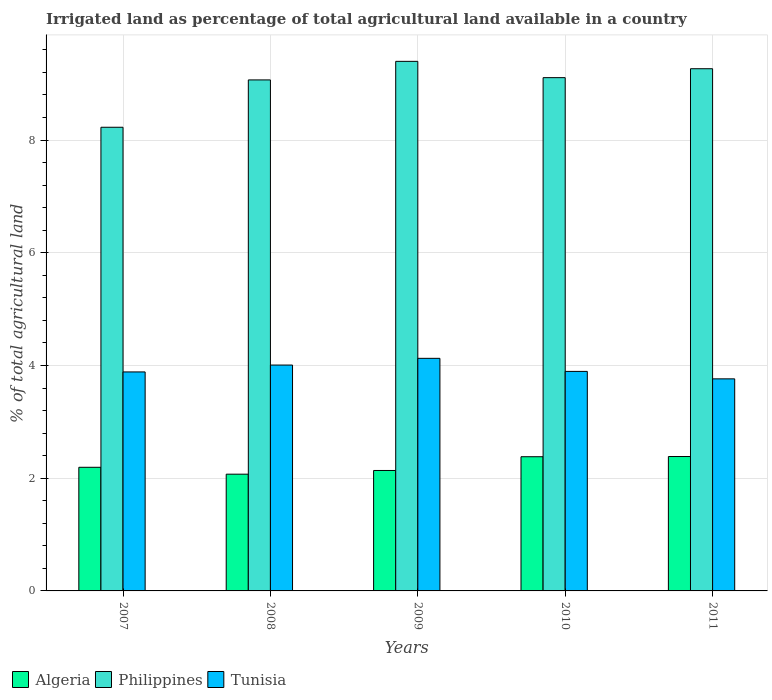How many different coloured bars are there?
Provide a short and direct response. 3. How many groups of bars are there?
Your answer should be compact. 5. Are the number of bars per tick equal to the number of legend labels?
Keep it short and to the point. Yes. Are the number of bars on each tick of the X-axis equal?
Make the answer very short. Yes. How many bars are there on the 4th tick from the left?
Your answer should be compact. 3. What is the percentage of irrigated land in Tunisia in 2009?
Offer a terse response. 4.13. Across all years, what is the maximum percentage of irrigated land in Algeria?
Ensure brevity in your answer.  2.38. Across all years, what is the minimum percentage of irrigated land in Philippines?
Your answer should be compact. 8.23. In which year was the percentage of irrigated land in Philippines minimum?
Provide a succinct answer. 2007. What is the total percentage of irrigated land in Tunisia in the graph?
Your answer should be compact. 19.68. What is the difference between the percentage of irrigated land in Tunisia in 2007 and that in 2009?
Provide a succinct answer. -0.24. What is the difference between the percentage of irrigated land in Algeria in 2011 and the percentage of irrigated land in Tunisia in 2009?
Give a very brief answer. -1.74. What is the average percentage of irrigated land in Algeria per year?
Your answer should be very brief. 2.23. In the year 2007, what is the difference between the percentage of irrigated land in Philippines and percentage of irrigated land in Tunisia?
Offer a terse response. 4.34. What is the ratio of the percentage of irrigated land in Algeria in 2008 to that in 2011?
Make the answer very short. 0.87. Is the percentage of irrigated land in Tunisia in 2010 less than that in 2011?
Your answer should be very brief. No. What is the difference between the highest and the second highest percentage of irrigated land in Algeria?
Provide a succinct answer. 0. What is the difference between the highest and the lowest percentage of irrigated land in Tunisia?
Offer a terse response. 0.36. In how many years, is the percentage of irrigated land in Algeria greater than the average percentage of irrigated land in Algeria taken over all years?
Provide a short and direct response. 2. Is the sum of the percentage of irrigated land in Algeria in 2007 and 2010 greater than the maximum percentage of irrigated land in Tunisia across all years?
Your answer should be very brief. Yes. What does the 2nd bar from the left in 2007 represents?
Offer a terse response. Philippines. What does the 2nd bar from the right in 2008 represents?
Keep it short and to the point. Philippines. How many years are there in the graph?
Ensure brevity in your answer.  5. Are the values on the major ticks of Y-axis written in scientific E-notation?
Your answer should be compact. No. How many legend labels are there?
Keep it short and to the point. 3. How are the legend labels stacked?
Keep it short and to the point. Horizontal. What is the title of the graph?
Make the answer very short. Irrigated land as percentage of total agricultural land available in a country. Does "Palau" appear as one of the legend labels in the graph?
Offer a very short reply. No. What is the label or title of the X-axis?
Your answer should be compact. Years. What is the label or title of the Y-axis?
Your answer should be compact. % of total agricultural land. What is the % of total agricultural land of Algeria in 2007?
Offer a terse response. 2.19. What is the % of total agricultural land of Philippines in 2007?
Keep it short and to the point. 8.23. What is the % of total agricultural land in Tunisia in 2007?
Offer a terse response. 3.89. What is the % of total agricultural land in Algeria in 2008?
Give a very brief answer. 2.07. What is the % of total agricultural land of Philippines in 2008?
Make the answer very short. 9.07. What is the % of total agricultural land in Tunisia in 2008?
Provide a short and direct response. 4.01. What is the % of total agricultural land in Algeria in 2009?
Provide a short and direct response. 2.14. What is the % of total agricultural land in Philippines in 2009?
Your answer should be very brief. 9.4. What is the % of total agricultural land in Tunisia in 2009?
Offer a very short reply. 4.13. What is the % of total agricultural land of Algeria in 2010?
Give a very brief answer. 2.38. What is the % of total agricultural land in Philippines in 2010?
Offer a terse response. 9.11. What is the % of total agricultural land in Tunisia in 2010?
Keep it short and to the point. 3.9. What is the % of total agricultural land in Algeria in 2011?
Provide a short and direct response. 2.38. What is the % of total agricultural land in Philippines in 2011?
Give a very brief answer. 9.27. What is the % of total agricultural land in Tunisia in 2011?
Your answer should be compact. 3.76. Across all years, what is the maximum % of total agricultural land in Algeria?
Offer a very short reply. 2.38. Across all years, what is the maximum % of total agricultural land in Philippines?
Ensure brevity in your answer.  9.4. Across all years, what is the maximum % of total agricultural land in Tunisia?
Offer a terse response. 4.13. Across all years, what is the minimum % of total agricultural land in Algeria?
Keep it short and to the point. 2.07. Across all years, what is the minimum % of total agricultural land of Philippines?
Offer a terse response. 8.23. Across all years, what is the minimum % of total agricultural land of Tunisia?
Keep it short and to the point. 3.76. What is the total % of total agricultural land in Algeria in the graph?
Your answer should be compact. 11.17. What is the total % of total agricultural land of Philippines in the graph?
Your answer should be very brief. 45.06. What is the total % of total agricultural land of Tunisia in the graph?
Make the answer very short. 19.68. What is the difference between the % of total agricultural land of Algeria in 2007 and that in 2008?
Your response must be concise. 0.12. What is the difference between the % of total agricultural land of Philippines in 2007 and that in 2008?
Your response must be concise. -0.84. What is the difference between the % of total agricultural land in Tunisia in 2007 and that in 2008?
Your answer should be compact. -0.12. What is the difference between the % of total agricultural land of Algeria in 2007 and that in 2009?
Give a very brief answer. 0.06. What is the difference between the % of total agricultural land of Philippines in 2007 and that in 2009?
Ensure brevity in your answer.  -1.17. What is the difference between the % of total agricultural land in Tunisia in 2007 and that in 2009?
Offer a terse response. -0.24. What is the difference between the % of total agricultural land in Algeria in 2007 and that in 2010?
Provide a succinct answer. -0.19. What is the difference between the % of total agricultural land in Philippines in 2007 and that in 2010?
Offer a very short reply. -0.88. What is the difference between the % of total agricultural land in Tunisia in 2007 and that in 2010?
Make the answer very short. -0.01. What is the difference between the % of total agricultural land of Algeria in 2007 and that in 2011?
Provide a short and direct response. -0.19. What is the difference between the % of total agricultural land of Philippines in 2007 and that in 2011?
Provide a succinct answer. -1.04. What is the difference between the % of total agricultural land of Tunisia in 2007 and that in 2011?
Make the answer very short. 0.12. What is the difference between the % of total agricultural land of Algeria in 2008 and that in 2009?
Your answer should be very brief. -0.07. What is the difference between the % of total agricultural land of Philippines in 2008 and that in 2009?
Your response must be concise. -0.33. What is the difference between the % of total agricultural land in Tunisia in 2008 and that in 2009?
Provide a short and direct response. -0.12. What is the difference between the % of total agricultural land in Algeria in 2008 and that in 2010?
Give a very brief answer. -0.31. What is the difference between the % of total agricultural land of Philippines in 2008 and that in 2010?
Give a very brief answer. -0.04. What is the difference between the % of total agricultural land in Tunisia in 2008 and that in 2010?
Offer a terse response. 0.11. What is the difference between the % of total agricultural land of Algeria in 2008 and that in 2011?
Provide a succinct answer. -0.31. What is the difference between the % of total agricultural land of Philippines in 2008 and that in 2011?
Give a very brief answer. -0.2. What is the difference between the % of total agricultural land of Tunisia in 2008 and that in 2011?
Your response must be concise. 0.24. What is the difference between the % of total agricultural land of Algeria in 2009 and that in 2010?
Ensure brevity in your answer.  -0.24. What is the difference between the % of total agricultural land of Philippines in 2009 and that in 2010?
Offer a terse response. 0.29. What is the difference between the % of total agricultural land in Tunisia in 2009 and that in 2010?
Your response must be concise. 0.23. What is the difference between the % of total agricultural land in Algeria in 2009 and that in 2011?
Offer a very short reply. -0.25. What is the difference between the % of total agricultural land of Philippines in 2009 and that in 2011?
Offer a very short reply. 0.13. What is the difference between the % of total agricultural land in Tunisia in 2009 and that in 2011?
Keep it short and to the point. 0.36. What is the difference between the % of total agricultural land in Algeria in 2010 and that in 2011?
Keep it short and to the point. -0. What is the difference between the % of total agricultural land in Philippines in 2010 and that in 2011?
Provide a short and direct response. -0.16. What is the difference between the % of total agricultural land in Tunisia in 2010 and that in 2011?
Provide a short and direct response. 0.13. What is the difference between the % of total agricultural land in Algeria in 2007 and the % of total agricultural land in Philippines in 2008?
Offer a very short reply. -6.87. What is the difference between the % of total agricultural land of Algeria in 2007 and the % of total agricultural land of Tunisia in 2008?
Your response must be concise. -1.81. What is the difference between the % of total agricultural land in Philippines in 2007 and the % of total agricultural land in Tunisia in 2008?
Give a very brief answer. 4.22. What is the difference between the % of total agricultural land in Algeria in 2007 and the % of total agricultural land in Philippines in 2009?
Keep it short and to the point. -7.2. What is the difference between the % of total agricultural land in Algeria in 2007 and the % of total agricultural land in Tunisia in 2009?
Give a very brief answer. -1.93. What is the difference between the % of total agricultural land in Philippines in 2007 and the % of total agricultural land in Tunisia in 2009?
Provide a succinct answer. 4.1. What is the difference between the % of total agricultural land of Algeria in 2007 and the % of total agricultural land of Philippines in 2010?
Provide a short and direct response. -6.91. What is the difference between the % of total agricultural land of Algeria in 2007 and the % of total agricultural land of Tunisia in 2010?
Ensure brevity in your answer.  -1.7. What is the difference between the % of total agricultural land of Philippines in 2007 and the % of total agricultural land of Tunisia in 2010?
Offer a terse response. 4.33. What is the difference between the % of total agricultural land of Algeria in 2007 and the % of total agricultural land of Philippines in 2011?
Keep it short and to the point. -7.07. What is the difference between the % of total agricultural land of Algeria in 2007 and the % of total agricultural land of Tunisia in 2011?
Make the answer very short. -1.57. What is the difference between the % of total agricultural land of Philippines in 2007 and the % of total agricultural land of Tunisia in 2011?
Your response must be concise. 4.46. What is the difference between the % of total agricultural land in Algeria in 2008 and the % of total agricultural land in Philippines in 2009?
Offer a very short reply. -7.33. What is the difference between the % of total agricultural land in Algeria in 2008 and the % of total agricultural land in Tunisia in 2009?
Ensure brevity in your answer.  -2.06. What is the difference between the % of total agricultural land of Philippines in 2008 and the % of total agricultural land of Tunisia in 2009?
Keep it short and to the point. 4.94. What is the difference between the % of total agricultural land in Algeria in 2008 and the % of total agricultural land in Philippines in 2010?
Make the answer very short. -7.04. What is the difference between the % of total agricultural land in Algeria in 2008 and the % of total agricultural land in Tunisia in 2010?
Offer a terse response. -1.82. What is the difference between the % of total agricultural land in Philippines in 2008 and the % of total agricultural land in Tunisia in 2010?
Provide a succinct answer. 5.17. What is the difference between the % of total agricultural land in Algeria in 2008 and the % of total agricultural land in Philippines in 2011?
Your response must be concise. -7.19. What is the difference between the % of total agricultural land of Algeria in 2008 and the % of total agricultural land of Tunisia in 2011?
Your answer should be very brief. -1.69. What is the difference between the % of total agricultural land of Philippines in 2008 and the % of total agricultural land of Tunisia in 2011?
Your answer should be compact. 5.3. What is the difference between the % of total agricultural land of Algeria in 2009 and the % of total agricultural land of Philippines in 2010?
Keep it short and to the point. -6.97. What is the difference between the % of total agricultural land of Algeria in 2009 and the % of total agricultural land of Tunisia in 2010?
Keep it short and to the point. -1.76. What is the difference between the % of total agricultural land of Philippines in 2009 and the % of total agricultural land of Tunisia in 2010?
Offer a very short reply. 5.5. What is the difference between the % of total agricultural land of Algeria in 2009 and the % of total agricultural land of Philippines in 2011?
Offer a terse response. -7.13. What is the difference between the % of total agricultural land in Algeria in 2009 and the % of total agricultural land in Tunisia in 2011?
Your answer should be compact. -1.63. What is the difference between the % of total agricultural land of Philippines in 2009 and the % of total agricultural land of Tunisia in 2011?
Ensure brevity in your answer.  5.63. What is the difference between the % of total agricultural land in Algeria in 2010 and the % of total agricultural land in Philippines in 2011?
Ensure brevity in your answer.  -6.88. What is the difference between the % of total agricultural land of Algeria in 2010 and the % of total agricultural land of Tunisia in 2011?
Ensure brevity in your answer.  -1.38. What is the difference between the % of total agricultural land of Philippines in 2010 and the % of total agricultural land of Tunisia in 2011?
Keep it short and to the point. 5.34. What is the average % of total agricultural land of Algeria per year?
Your answer should be compact. 2.23. What is the average % of total agricultural land in Philippines per year?
Provide a succinct answer. 9.01. What is the average % of total agricultural land in Tunisia per year?
Provide a short and direct response. 3.94. In the year 2007, what is the difference between the % of total agricultural land in Algeria and % of total agricultural land in Philippines?
Your response must be concise. -6.03. In the year 2007, what is the difference between the % of total agricultural land of Algeria and % of total agricultural land of Tunisia?
Provide a succinct answer. -1.69. In the year 2007, what is the difference between the % of total agricultural land in Philippines and % of total agricultural land in Tunisia?
Give a very brief answer. 4.34. In the year 2008, what is the difference between the % of total agricultural land in Algeria and % of total agricultural land in Philippines?
Ensure brevity in your answer.  -7. In the year 2008, what is the difference between the % of total agricultural land in Algeria and % of total agricultural land in Tunisia?
Make the answer very short. -1.94. In the year 2008, what is the difference between the % of total agricultural land of Philippines and % of total agricultural land of Tunisia?
Make the answer very short. 5.06. In the year 2009, what is the difference between the % of total agricultural land of Algeria and % of total agricultural land of Philippines?
Make the answer very short. -7.26. In the year 2009, what is the difference between the % of total agricultural land in Algeria and % of total agricultural land in Tunisia?
Your response must be concise. -1.99. In the year 2009, what is the difference between the % of total agricultural land in Philippines and % of total agricultural land in Tunisia?
Ensure brevity in your answer.  5.27. In the year 2010, what is the difference between the % of total agricultural land in Algeria and % of total agricultural land in Philippines?
Your answer should be compact. -6.73. In the year 2010, what is the difference between the % of total agricultural land of Algeria and % of total agricultural land of Tunisia?
Your answer should be very brief. -1.51. In the year 2010, what is the difference between the % of total agricultural land of Philippines and % of total agricultural land of Tunisia?
Your response must be concise. 5.21. In the year 2011, what is the difference between the % of total agricultural land in Algeria and % of total agricultural land in Philippines?
Provide a succinct answer. -6.88. In the year 2011, what is the difference between the % of total agricultural land of Algeria and % of total agricultural land of Tunisia?
Give a very brief answer. -1.38. In the year 2011, what is the difference between the % of total agricultural land of Philippines and % of total agricultural land of Tunisia?
Keep it short and to the point. 5.5. What is the ratio of the % of total agricultural land in Algeria in 2007 to that in 2008?
Your response must be concise. 1.06. What is the ratio of the % of total agricultural land of Philippines in 2007 to that in 2008?
Make the answer very short. 0.91. What is the ratio of the % of total agricultural land of Tunisia in 2007 to that in 2008?
Offer a terse response. 0.97. What is the ratio of the % of total agricultural land of Algeria in 2007 to that in 2009?
Offer a very short reply. 1.03. What is the ratio of the % of total agricultural land of Philippines in 2007 to that in 2009?
Ensure brevity in your answer.  0.88. What is the ratio of the % of total agricultural land of Tunisia in 2007 to that in 2009?
Your answer should be very brief. 0.94. What is the ratio of the % of total agricultural land in Algeria in 2007 to that in 2010?
Provide a short and direct response. 0.92. What is the ratio of the % of total agricultural land in Philippines in 2007 to that in 2010?
Your answer should be compact. 0.9. What is the ratio of the % of total agricultural land in Algeria in 2007 to that in 2011?
Your response must be concise. 0.92. What is the ratio of the % of total agricultural land in Philippines in 2007 to that in 2011?
Offer a terse response. 0.89. What is the ratio of the % of total agricultural land of Tunisia in 2007 to that in 2011?
Provide a succinct answer. 1.03. What is the ratio of the % of total agricultural land of Algeria in 2008 to that in 2009?
Your response must be concise. 0.97. What is the ratio of the % of total agricultural land in Philippines in 2008 to that in 2009?
Your answer should be very brief. 0.96. What is the ratio of the % of total agricultural land in Tunisia in 2008 to that in 2009?
Make the answer very short. 0.97. What is the ratio of the % of total agricultural land of Algeria in 2008 to that in 2010?
Give a very brief answer. 0.87. What is the ratio of the % of total agricultural land of Philippines in 2008 to that in 2010?
Keep it short and to the point. 1. What is the ratio of the % of total agricultural land in Tunisia in 2008 to that in 2010?
Ensure brevity in your answer.  1.03. What is the ratio of the % of total agricultural land in Algeria in 2008 to that in 2011?
Provide a short and direct response. 0.87. What is the ratio of the % of total agricultural land of Philippines in 2008 to that in 2011?
Give a very brief answer. 0.98. What is the ratio of the % of total agricultural land of Tunisia in 2008 to that in 2011?
Provide a succinct answer. 1.07. What is the ratio of the % of total agricultural land in Algeria in 2009 to that in 2010?
Your answer should be compact. 0.9. What is the ratio of the % of total agricultural land in Philippines in 2009 to that in 2010?
Your response must be concise. 1.03. What is the ratio of the % of total agricultural land of Tunisia in 2009 to that in 2010?
Your answer should be very brief. 1.06. What is the ratio of the % of total agricultural land of Algeria in 2009 to that in 2011?
Give a very brief answer. 0.9. What is the ratio of the % of total agricultural land in Philippines in 2009 to that in 2011?
Offer a terse response. 1.01. What is the ratio of the % of total agricultural land of Tunisia in 2009 to that in 2011?
Your response must be concise. 1.1. What is the ratio of the % of total agricultural land in Algeria in 2010 to that in 2011?
Keep it short and to the point. 1. What is the ratio of the % of total agricultural land of Philippines in 2010 to that in 2011?
Provide a short and direct response. 0.98. What is the ratio of the % of total agricultural land in Tunisia in 2010 to that in 2011?
Your answer should be compact. 1.04. What is the difference between the highest and the second highest % of total agricultural land in Algeria?
Keep it short and to the point. 0. What is the difference between the highest and the second highest % of total agricultural land of Philippines?
Offer a terse response. 0.13. What is the difference between the highest and the second highest % of total agricultural land in Tunisia?
Keep it short and to the point. 0.12. What is the difference between the highest and the lowest % of total agricultural land of Algeria?
Your answer should be compact. 0.31. What is the difference between the highest and the lowest % of total agricultural land of Philippines?
Give a very brief answer. 1.17. What is the difference between the highest and the lowest % of total agricultural land in Tunisia?
Make the answer very short. 0.36. 